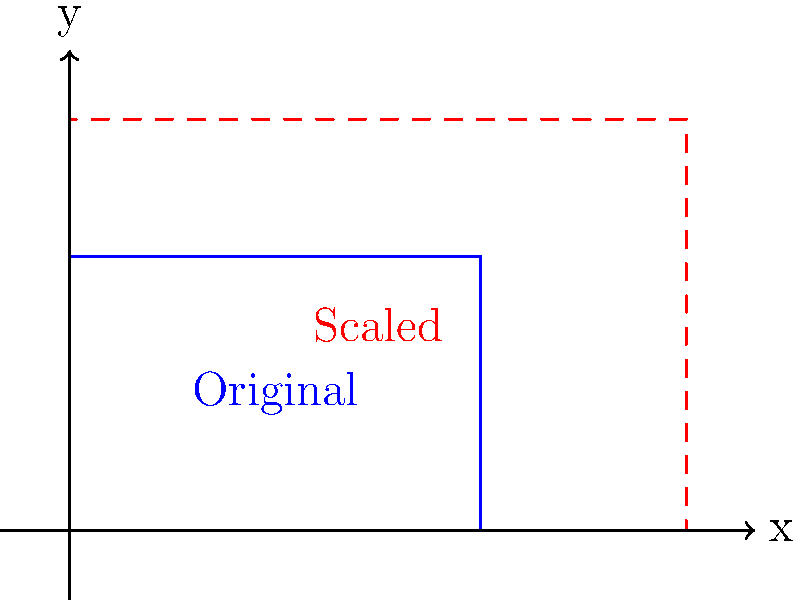As the stage manager of a renowned opera company, you're tasked with adapting the seating chart for a new venue. The original seating area is represented by a rectangle measuring 6 units wide and 4 units tall. The new venue requires the seating area to be scaled up to 9 units wide and 6 units tall. What scale factor should be applied to transform the original seating chart to fit the new venue? To find the scale factor, we need to compare the dimensions of the new seating area to the original one. Let's approach this step-by-step:

1. Original dimensions: 6 units wide, 4 units tall
2. New dimensions: 9 units wide, 6 units tall

3. Calculate the scale factor for width:
   $\text{Scale factor}_{\text{width}} = \frac{\text{New width}}{\text{Original width}} = \frac{9}{6} = 1.5$

4. Calculate the scale factor for height:
   $\text{Scale factor}_{\text{height}} = \frac{\text{New height}}{\text{Original height}} = \frac{6}{4} = 1.5$

5. We observe that both the width and height have the same scale factor of 1.5.

6. This uniform scale factor means that the seating chart is being enlarged proportionally in both dimensions, maintaining its aspect ratio.

Therefore, to transform the original seating chart to fit the new venue, we need to apply a scale factor of 1.5 to both dimensions.
Answer: 1.5 